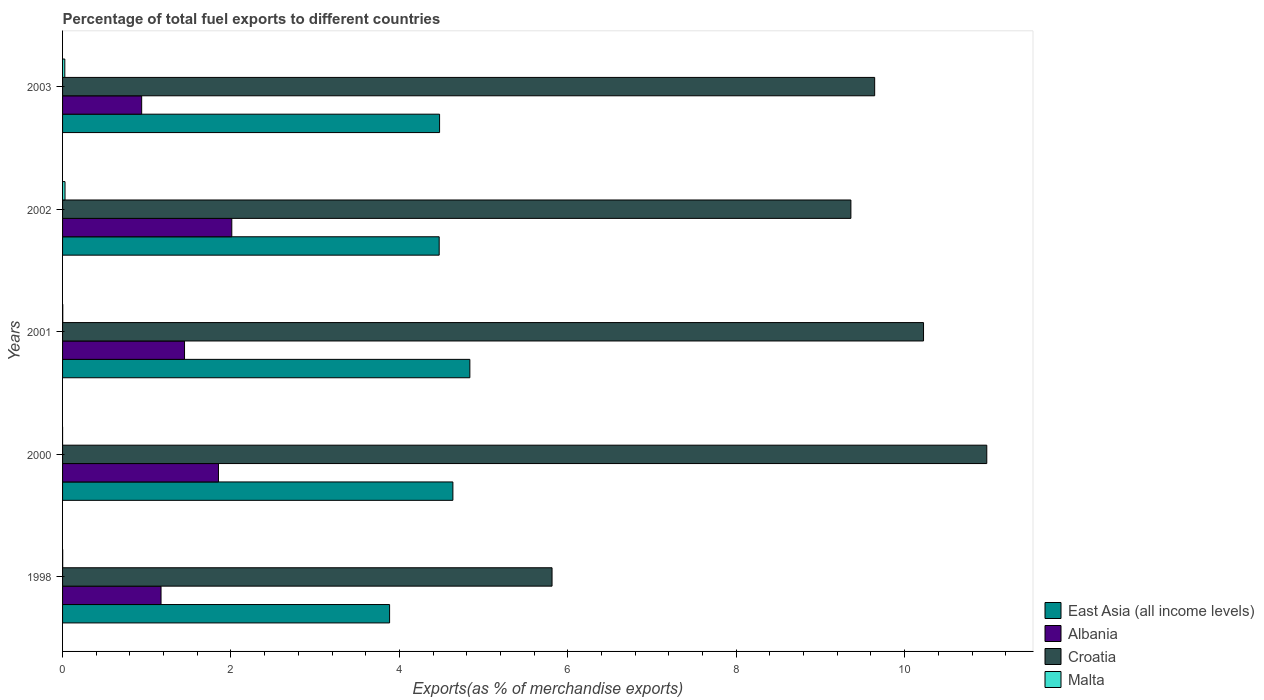Are the number of bars per tick equal to the number of legend labels?
Offer a very short reply. Yes. How many bars are there on the 4th tick from the bottom?
Your answer should be very brief. 4. In how many cases, is the number of bars for a given year not equal to the number of legend labels?
Provide a short and direct response. 0. What is the percentage of exports to different countries in Croatia in 2003?
Make the answer very short. 9.64. Across all years, what is the maximum percentage of exports to different countries in East Asia (all income levels)?
Provide a short and direct response. 4.84. Across all years, what is the minimum percentage of exports to different countries in East Asia (all income levels)?
Offer a terse response. 3.88. In which year was the percentage of exports to different countries in Croatia maximum?
Offer a terse response. 2000. What is the total percentage of exports to different countries in Albania in the graph?
Ensure brevity in your answer.  7.42. What is the difference between the percentage of exports to different countries in East Asia (all income levels) in 2000 and that in 2002?
Keep it short and to the point. 0.16. What is the difference between the percentage of exports to different countries in Albania in 2000 and the percentage of exports to different countries in East Asia (all income levels) in 1998?
Provide a short and direct response. -2.03. What is the average percentage of exports to different countries in Croatia per year?
Offer a very short reply. 9.2. In the year 2000, what is the difference between the percentage of exports to different countries in Malta and percentage of exports to different countries in Croatia?
Offer a terse response. -10.98. What is the ratio of the percentage of exports to different countries in Albania in 2001 to that in 2003?
Your response must be concise. 1.54. Is the difference between the percentage of exports to different countries in Malta in 2000 and 2003 greater than the difference between the percentage of exports to different countries in Croatia in 2000 and 2003?
Offer a very short reply. No. What is the difference between the highest and the second highest percentage of exports to different countries in East Asia (all income levels)?
Offer a very short reply. 0.2. What is the difference between the highest and the lowest percentage of exports to different countries in Albania?
Your answer should be very brief. 1.07. Is the sum of the percentage of exports to different countries in Malta in 2002 and 2003 greater than the maximum percentage of exports to different countries in Croatia across all years?
Your answer should be very brief. No. What does the 2nd bar from the top in 2003 represents?
Provide a short and direct response. Croatia. What does the 4th bar from the bottom in 2000 represents?
Make the answer very short. Malta. Is it the case that in every year, the sum of the percentage of exports to different countries in East Asia (all income levels) and percentage of exports to different countries in Albania is greater than the percentage of exports to different countries in Malta?
Your response must be concise. Yes. How many bars are there?
Offer a terse response. 20. How many years are there in the graph?
Your answer should be compact. 5. What is the difference between two consecutive major ticks on the X-axis?
Offer a very short reply. 2. Does the graph contain any zero values?
Offer a terse response. No. How many legend labels are there?
Provide a short and direct response. 4. What is the title of the graph?
Your response must be concise. Percentage of total fuel exports to different countries. Does "Honduras" appear as one of the legend labels in the graph?
Give a very brief answer. No. What is the label or title of the X-axis?
Provide a succinct answer. Exports(as % of merchandise exports). What is the label or title of the Y-axis?
Provide a succinct answer. Years. What is the Exports(as % of merchandise exports) of East Asia (all income levels) in 1998?
Ensure brevity in your answer.  3.88. What is the Exports(as % of merchandise exports) in Albania in 1998?
Offer a very short reply. 1.17. What is the Exports(as % of merchandise exports) of Croatia in 1998?
Your response must be concise. 5.81. What is the Exports(as % of merchandise exports) in Malta in 1998?
Make the answer very short. 0. What is the Exports(as % of merchandise exports) in East Asia (all income levels) in 2000?
Give a very brief answer. 4.64. What is the Exports(as % of merchandise exports) in Albania in 2000?
Offer a very short reply. 1.85. What is the Exports(as % of merchandise exports) of Croatia in 2000?
Provide a succinct answer. 10.98. What is the Exports(as % of merchandise exports) in Malta in 2000?
Give a very brief answer. 3.27668183292656e-5. What is the Exports(as % of merchandise exports) in East Asia (all income levels) in 2001?
Offer a very short reply. 4.84. What is the Exports(as % of merchandise exports) of Albania in 2001?
Provide a short and direct response. 1.45. What is the Exports(as % of merchandise exports) in Croatia in 2001?
Keep it short and to the point. 10.22. What is the Exports(as % of merchandise exports) in Malta in 2001?
Offer a very short reply. 0. What is the Exports(as % of merchandise exports) of East Asia (all income levels) in 2002?
Your answer should be very brief. 4.47. What is the Exports(as % of merchandise exports) in Albania in 2002?
Provide a succinct answer. 2.01. What is the Exports(as % of merchandise exports) in Croatia in 2002?
Keep it short and to the point. 9.36. What is the Exports(as % of merchandise exports) of Malta in 2002?
Provide a short and direct response. 0.03. What is the Exports(as % of merchandise exports) in East Asia (all income levels) in 2003?
Ensure brevity in your answer.  4.48. What is the Exports(as % of merchandise exports) in Albania in 2003?
Your response must be concise. 0.94. What is the Exports(as % of merchandise exports) in Croatia in 2003?
Provide a short and direct response. 9.64. What is the Exports(as % of merchandise exports) in Malta in 2003?
Make the answer very short. 0.03. Across all years, what is the maximum Exports(as % of merchandise exports) of East Asia (all income levels)?
Your answer should be compact. 4.84. Across all years, what is the maximum Exports(as % of merchandise exports) of Albania?
Give a very brief answer. 2.01. Across all years, what is the maximum Exports(as % of merchandise exports) in Croatia?
Provide a short and direct response. 10.98. Across all years, what is the maximum Exports(as % of merchandise exports) in Malta?
Give a very brief answer. 0.03. Across all years, what is the minimum Exports(as % of merchandise exports) of East Asia (all income levels)?
Your answer should be compact. 3.88. Across all years, what is the minimum Exports(as % of merchandise exports) in Albania?
Give a very brief answer. 0.94. Across all years, what is the minimum Exports(as % of merchandise exports) in Croatia?
Provide a short and direct response. 5.81. Across all years, what is the minimum Exports(as % of merchandise exports) in Malta?
Make the answer very short. 3.27668183292656e-5. What is the total Exports(as % of merchandise exports) of East Asia (all income levels) in the graph?
Offer a very short reply. 22.3. What is the total Exports(as % of merchandise exports) of Albania in the graph?
Provide a short and direct response. 7.42. What is the total Exports(as % of merchandise exports) of Croatia in the graph?
Give a very brief answer. 46.02. What is the total Exports(as % of merchandise exports) in Malta in the graph?
Your answer should be compact. 0.06. What is the difference between the Exports(as % of merchandise exports) of East Asia (all income levels) in 1998 and that in 2000?
Your response must be concise. -0.75. What is the difference between the Exports(as % of merchandise exports) in Albania in 1998 and that in 2000?
Offer a very short reply. -0.68. What is the difference between the Exports(as % of merchandise exports) in Croatia in 1998 and that in 2000?
Your answer should be very brief. -5.16. What is the difference between the Exports(as % of merchandise exports) in Malta in 1998 and that in 2000?
Your answer should be compact. 0. What is the difference between the Exports(as % of merchandise exports) of East Asia (all income levels) in 1998 and that in 2001?
Ensure brevity in your answer.  -0.95. What is the difference between the Exports(as % of merchandise exports) of Albania in 1998 and that in 2001?
Your answer should be very brief. -0.28. What is the difference between the Exports(as % of merchandise exports) in Croatia in 1998 and that in 2001?
Your response must be concise. -4.41. What is the difference between the Exports(as % of merchandise exports) in Malta in 1998 and that in 2001?
Provide a succinct answer. -0. What is the difference between the Exports(as % of merchandise exports) in East Asia (all income levels) in 1998 and that in 2002?
Your response must be concise. -0.59. What is the difference between the Exports(as % of merchandise exports) in Albania in 1998 and that in 2002?
Your answer should be very brief. -0.84. What is the difference between the Exports(as % of merchandise exports) of Croatia in 1998 and that in 2002?
Your response must be concise. -3.55. What is the difference between the Exports(as % of merchandise exports) in Malta in 1998 and that in 2002?
Offer a terse response. -0.03. What is the difference between the Exports(as % of merchandise exports) in East Asia (all income levels) in 1998 and that in 2003?
Offer a terse response. -0.59. What is the difference between the Exports(as % of merchandise exports) in Albania in 1998 and that in 2003?
Ensure brevity in your answer.  0.23. What is the difference between the Exports(as % of merchandise exports) of Croatia in 1998 and that in 2003?
Provide a succinct answer. -3.83. What is the difference between the Exports(as % of merchandise exports) of Malta in 1998 and that in 2003?
Your answer should be compact. -0.03. What is the difference between the Exports(as % of merchandise exports) of East Asia (all income levels) in 2000 and that in 2001?
Provide a short and direct response. -0.2. What is the difference between the Exports(as % of merchandise exports) of Albania in 2000 and that in 2001?
Provide a succinct answer. 0.4. What is the difference between the Exports(as % of merchandise exports) in Croatia in 2000 and that in 2001?
Keep it short and to the point. 0.75. What is the difference between the Exports(as % of merchandise exports) in Malta in 2000 and that in 2001?
Provide a short and direct response. -0. What is the difference between the Exports(as % of merchandise exports) in East Asia (all income levels) in 2000 and that in 2002?
Ensure brevity in your answer.  0.16. What is the difference between the Exports(as % of merchandise exports) in Albania in 2000 and that in 2002?
Offer a terse response. -0.16. What is the difference between the Exports(as % of merchandise exports) of Croatia in 2000 and that in 2002?
Give a very brief answer. 1.61. What is the difference between the Exports(as % of merchandise exports) in Malta in 2000 and that in 2002?
Make the answer very short. -0.03. What is the difference between the Exports(as % of merchandise exports) in East Asia (all income levels) in 2000 and that in 2003?
Offer a terse response. 0.16. What is the difference between the Exports(as % of merchandise exports) in Albania in 2000 and that in 2003?
Provide a succinct answer. 0.91. What is the difference between the Exports(as % of merchandise exports) in Croatia in 2000 and that in 2003?
Give a very brief answer. 1.33. What is the difference between the Exports(as % of merchandise exports) in Malta in 2000 and that in 2003?
Offer a terse response. -0.03. What is the difference between the Exports(as % of merchandise exports) of East Asia (all income levels) in 2001 and that in 2002?
Give a very brief answer. 0.36. What is the difference between the Exports(as % of merchandise exports) in Albania in 2001 and that in 2002?
Your answer should be compact. -0.56. What is the difference between the Exports(as % of merchandise exports) of Croatia in 2001 and that in 2002?
Your answer should be very brief. 0.86. What is the difference between the Exports(as % of merchandise exports) in Malta in 2001 and that in 2002?
Provide a succinct answer. -0.03. What is the difference between the Exports(as % of merchandise exports) of East Asia (all income levels) in 2001 and that in 2003?
Give a very brief answer. 0.36. What is the difference between the Exports(as % of merchandise exports) in Albania in 2001 and that in 2003?
Keep it short and to the point. 0.51. What is the difference between the Exports(as % of merchandise exports) of Croatia in 2001 and that in 2003?
Your answer should be very brief. 0.58. What is the difference between the Exports(as % of merchandise exports) in Malta in 2001 and that in 2003?
Make the answer very short. -0.02. What is the difference between the Exports(as % of merchandise exports) in East Asia (all income levels) in 2002 and that in 2003?
Ensure brevity in your answer.  -0. What is the difference between the Exports(as % of merchandise exports) of Albania in 2002 and that in 2003?
Your response must be concise. 1.07. What is the difference between the Exports(as % of merchandise exports) of Croatia in 2002 and that in 2003?
Keep it short and to the point. -0.28. What is the difference between the Exports(as % of merchandise exports) of Malta in 2002 and that in 2003?
Keep it short and to the point. 0. What is the difference between the Exports(as % of merchandise exports) of East Asia (all income levels) in 1998 and the Exports(as % of merchandise exports) of Albania in 2000?
Offer a terse response. 2.03. What is the difference between the Exports(as % of merchandise exports) in East Asia (all income levels) in 1998 and the Exports(as % of merchandise exports) in Croatia in 2000?
Offer a terse response. -7.09. What is the difference between the Exports(as % of merchandise exports) of East Asia (all income levels) in 1998 and the Exports(as % of merchandise exports) of Malta in 2000?
Your answer should be very brief. 3.88. What is the difference between the Exports(as % of merchandise exports) in Albania in 1998 and the Exports(as % of merchandise exports) in Croatia in 2000?
Offer a terse response. -9.81. What is the difference between the Exports(as % of merchandise exports) of Albania in 1998 and the Exports(as % of merchandise exports) of Malta in 2000?
Your answer should be compact. 1.17. What is the difference between the Exports(as % of merchandise exports) of Croatia in 1998 and the Exports(as % of merchandise exports) of Malta in 2000?
Your response must be concise. 5.81. What is the difference between the Exports(as % of merchandise exports) of East Asia (all income levels) in 1998 and the Exports(as % of merchandise exports) of Albania in 2001?
Make the answer very short. 2.44. What is the difference between the Exports(as % of merchandise exports) in East Asia (all income levels) in 1998 and the Exports(as % of merchandise exports) in Croatia in 2001?
Give a very brief answer. -6.34. What is the difference between the Exports(as % of merchandise exports) of East Asia (all income levels) in 1998 and the Exports(as % of merchandise exports) of Malta in 2001?
Provide a succinct answer. 3.88. What is the difference between the Exports(as % of merchandise exports) of Albania in 1998 and the Exports(as % of merchandise exports) of Croatia in 2001?
Offer a very short reply. -9.05. What is the difference between the Exports(as % of merchandise exports) in Albania in 1998 and the Exports(as % of merchandise exports) in Malta in 2001?
Offer a very short reply. 1.17. What is the difference between the Exports(as % of merchandise exports) in Croatia in 1998 and the Exports(as % of merchandise exports) in Malta in 2001?
Offer a terse response. 5.81. What is the difference between the Exports(as % of merchandise exports) of East Asia (all income levels) in 1998 and the Exports(as % of merchandise exports) of Albania in 2002?
Your answer should be very brief. 1.87. What is the difference between the Exports(as % of merchandise exports) in East Asia (all income levels) in 1998 and the Exports(as % of merchandise exports) in Croatia in 2002?
Give a very brief answer. -5.48. What is the difference between the Exports(as % of merchandise exports) of East Asia (all income levels) in 1998 and the Exports(as % of merchandise exports) of Malta in 2002?
Provide a short and direct response. 3.85. What is the difference between the Exports(as % of merchandise exports) in Albania in 1998 and the Exports(as % of merchandise exports) in Croatia in 2002?
Your response must be concise. -8.19. What is the difference between the Exports(as % of merchandise exports) in Albania in 1998 and the Exports(as % of merchandise exports) in Malta in 2002?
Your response must be concise. 1.14. What is the difference between the Exports(as % of merchandise exports) in Croatia in 1998 and the Exports(as % of merchandise exports) in Malta in 2002?
Give a very brief answer. 5.78. What is the difference between the Exports(as % of merchandise exports) in East Asia (all income levels) in 1998 and the Exports(as % of merchandise exports) in Albania in 2003?
Offer a terse response. 2.94. What is the difference between the Exports(as % of merchandise exports) in East Asia (all income levels) in 1998 and the Exports(as % of merchandise exports) in Croatia in 2003?
Your response must be concise. -5.76. What is the difference between the Exports(as % of merchandise exports) of East Asia (all income levels) in 1998 and the Exports(as % of merchandise exports) of Malta in 2003?
Offer a terse response. 3.86. What is the difference between the Exports(as % of merchandise exports) in Albania in 1998 and the Exports(as % of merchandise exports) in Croatia in 2003?
Ensure brevity in your answer.  -8.47. What is the difference between the Exports(as % of merchandise exports) in Albania in 1998 and the Exports(as % of merchandise exports) in Malta in 2003?
Provide a succinct answer. 1.14. What is the difference between the Exports(as % of merchandise exports) in Croatia in 1998 and the Exports(as % of merchandise exports) in Malta in 2003?
Your answer should be compact. 5.79. What is the difference between the Exports(as % of merchandise exports) in East Asia (all income levels) in 2000 and the Exports(as % of merchandise exports) in Albania in 2001?
Ensure brevity in your answer.  3.19. What is the difference between the Exports(as % of merchandise exports) of East Asia (all income levels) in 2000 and the Exports(as % of merchandise exports) of Croatia in 2001?
Provide a succinct answer. -5.59. What is the difference between the Exports(as % of merchandise exports) in East Asia (all income levels) in 2000 and the Exports(as % of merchandise exports) in Malta in 2001?
Give a very brief answer. 4.63. What is the difference between the Exports(as % of merchandise exports) in Albania in 2000 and the Exports(as % of merchandise exports) in Croatia in 2001?
Keep it short and to the point. -8.37. What is the difference between the Exports(as % of merchandise exports) in Albania in 2000 and the Exports(as % of merchandise exports) in Malta in 2001?
Your answer should be very brief. 1.85. What is the difference between the Exports(as % of merchandise exports) in Croatia in 2000 and the Exports(as % of merchandise exports) in Malta in 2001?
Offer a very short reply. 10.97. What is the difference between the Exports(as % of merchandise exports) of East Asia (all income levels) in 2000 and the Exports(as % of merchandise exports) of Albania in 2002?
Your answer should be very brief. 2.63. What is the difference between the Exports(as % of merchandise exports) in East Asia (all income levels) in 2000 and the Exports(as % of merchandise exports) in Croatia in 2002?
Keep it short and to the point. -4.73. What is the difference between the Exports(as % of merchandise exports) in East Asia (all income levels) in 2000 and the Exports(as % of merchandise exports) in Malta in 2002?
Keep it short and to the point. 4.61. What is the difference between the Exports(as % of merchandise exports) in Albania in 2000 and the Exports(as % of merchandise exports) in Croatia in 2002?
Offer a terse response. -7.51. What is the difference between the Exports(as % of merchandise exports) of Albania in 2000 and the Exports(as % of merchandise exports) of Malta in 2002?
Ensure brevity in your answer.  1.82. What is the difference between the Exports(as % of merchandise exports) of Croatia in 2000 and the Exports(as % of merchandise exports) of Malta in 2002?
Ensure brevity in your answer.  10.95. What is the difference between the Exports(as % of merchandise exports) in East Asia (all income levels) in 2000 and the Exports(as % of merchandise exports) in Albania in 2003?
Offer a very short reply. 3.7. What is the difference between the Exports(as % of merchandise exports) in East Asia (all income levels) in 2000 and the Exports(as % of merchandise exports) in Croatia in 2003?
Provide a short and direct response. -5.01. What is the difference between the Exports(as % of merchandise exports) in East Asia (all income levels) in 2000 and the Exports(as % of merchandise exports) in Malta in 2003?
Your response must be concise. 4.61. What is the difference between the Exports(as % of merchandise exports) in Albania in 2000 and the Exports(as % of merchandise exports) in Croatia in 2003?
Your answer should be very brief. -7.79. What is the difference between the Exports(as % of merchandise exports) of Albania in 2000 and the Exports(as % of merchandise exports) of Malta in 2003?
Your response must be concise. 1.82. What is the difference between the Exports(as % of merchandise exports) of Croatia in 2000 and the Exports(as % of merchandise exports) of Malta in 2003?
Keep it short and to the point. 10.95. What is the difference between the Exports(as % of merchandise exports) in East Asia (all income levels) in 2001 and the Exports(as % of merchandise exports) in Albania in 2002?
Your answer should be very brief. 2.83. What is the difference between the Exports(as % of merchandise exports) of East Asia (all income levels) in 2001 and the Exports(as % of merchandise exports) of Croatia in 2002?
Offer a terse response. -4.52. What is the difference between the Exports(as % of merchandise exports) in East Asia (all income levels) in 2001 and the Exports(as % of merchandise exports) in Malta in 2002?
Your answer should be compact. 4.81. What is the difference between the Exports(as % of merchandise exports) in Albania in 2001 and the Exports(as % of merchandise exports) in Croatia in 2002?
Offer a very short reply. -7.91. What is the difference between the Exports(as % of merchandise exports) in Albania in 2001 and the Exports(as % of merchandise exports) in Malta in 2002?
Ensure brevity in your answer.  1.42. What is the difference between the Exports(as % of merchandise exports) of Croatia in 2001 and the Exports(as % of merchandise exports) of Malta in 2002?
Your answer should be compact. 10.19. What is the difference between the Exports(as % of merchandise exports) of East Asia (all income levels) in 2001 and the Exports(as % of merchandise exports) of Albania in 2003?
Your response must be concise. 3.9. What is the difference between the Exports(as % of merchandise exports) of East Asia (all income levels) in 2001 and the Exports(as % of merchandise exports) of Croatia in 2003?
Ensure brevity in your answer.  -4.81. What is the difference between the Exports(as % of merchandise exports) in East Asia (all income levels) in 2001 and the Exports(as % of merchandise exports) in Malta in 2003?
Your answer should be very brief. 4.81. What is the difference between the Exports(as % of merchandise exports) of Albania in 2001 and the Exports(as % of merchandise exports) of Croatia in 2003?
Keep it short and to the point. -8.2. What is the difference between the Exports(as % of merchandise exports) of Albania in 2001 and the Exports(as % of merchandise exports) of Malta in 2003?
Keep it short and to the point. 1.42. What is the difference between the Exports(as % of merchandise exports) in Croatia in 2001 and the Exports(as % of merchandise exports) in Malta in 2003?
Provide a succinct answer. 10.2. What is the difference between the Exports(as % of merchandise exports) of East Asia (all income levels) in 2002 and the Exports(as % of merchandise exports) of Albania in 2003?
Your answer should be compact. 3.53. What is the difference between the Exports(as % of merchandise exports) of East Asia (all income levels) in 2002 and the Exports(as % of merchandise exports) of Croatia in 2003?
Ensure brevity in your answer.  -5.17. What is the difference between the Exports(as % of merchandise exports) in East Asia (all income levels) in 2002 and the Exports(as % of merchandise exports) in Malta in 2003?
Ensure brevity in your answer.  4.45. What is the difference between the Exports(as % of merchandise exports) in Albania in 2002 and the Exports(as % of merchandise exports) in Croatia in 2003?
Offer a very short reply. -7.63. What is the difference between the Exports(as % of merchandise exports) of Albania in 2002 and the Exports(as % of merchandise exports) of Malta in 2003?
Your answer should be compact. 1.98. What is the difference between the Exports(as % of merchandise exports) in Croatia in 2002 and the Exports(as % of merchandise exports) in Malta in 2003?
Make the answer very short. 9.33. What is the average Exports(as % of merchandise exports) of East Asia (all income levels) per year?
Your answer should be compact. 4.46. What is the average Exports(as % of merchandise exports) of Albania per year?
Offer a terse response. 1.48. What is the average Exports(as % of merchandise exports) of Croatia per year?
Provide a short and direct response. 9.2. What is the average Exports(as % of merchandise exports) of Malta per year?
Your answer should be very brief. 0.01. In the year 1998, what is the difference between the Exports(as % of merchandise exports) in East Asia (all income levels) and Exports(as % of merchandise exports) in Albania?
Your response must be concise. 2.71. In the year 1998, what is the difference between the Exports(as % of merchandise exports) in East Asia (all income levels) and Exports(as % of merchandise exports) in Croatia?
Provide a short and direct response. -1.93. In the year 1998, what is the difference between the Exports(as % of merchandise exports) in East Asia (all income levels) and Exports(as % of merchandise exports) in Malta?
Make the answer very short. 3.88. In the year 1998, what is the difference between the Exports(as % of merchandise exports) of Albania and Exports(as % of merchandise exports) of Croatia?
Offer a very short reply. -4.64. In the year 1998, what is the difference between the Exports(as % of merchandise exports) of Albania and Exports(as % of merchandise exports) of Malta?
Keep it short and to the point. 1.17. In the year 1998, what is the difference between the Exports(as % of merchandise exports) of Croatia and Exports(as % of merchandise exports) of Malta?
Your answer should be compact. 5.81. In the year 2000, what is the difference between the Exports(as % of merchandise exports) in East Asia (all income levels) and Exports(as % of merchandise exports) in Albania?
Provide a short and direct response. 2.78. In the year 2000, what is the difference between the Exports(as % of merchandise exports) in East Asia (all income levels) and Exports(as % of merchandise exports) in Croatia?
Provide a short and direct response. -6.34. In the year 2000, what is the difference between the Exports(as % of merchandise exports) in East Asia (all income levels) and Exports(as % of merchandise exports) in Malta?
Your response must be concise. 4.64. In the year 2000, what is the difference between the Exports(as % of merchandise exports) of Albania and Exports(as % of merchandise exports) of Croatia?
Keep it short and to the point. -9.12. In the year 2000, what is the difference between the Exports(as % of merchandise exports) in Albania and Exports(as % of merchandise exports) in Malta?
Keep it short and to the point. 1.85. In the year 2000, what is the difference between the Exports(as % of merchandise exports) in Croatia and Exports(as % of merchandise exports) in Malta?
Your response must be concise. 10.97. In the year 2001, what is the difference between the Exports(as % of merchandise exports) in East Asia (all income levels) and Exports(as % of merchandise exports) in Albania?
Offer a very short reply. 3.39. In the year 2001, what is the difference between the Exports(as % of merchandise exports) of East Asia (all income levels) and Exports(as % of merchandise exports) of Croatia?
Provide a short and direct response. -5.39. In the year 2001, what is the difference between the Exports(as % of merchandise exports) of East Asia (all income levels) and Exports(as % of merchandise exports) of Malta?
Your answer should be very brief. 4.83. In the year 2001, what is the difference between the Exports(as % of merchandise exports) in Albania and Exports(as % of merchandise exports) in Croatia?
Provide a succinct answer. -8.78. In the year 2001, what is the difference between the Exports(as % of merchandise exports) in Albania and Exports(as % of merchandise exports) in Malta?
Provide a succinct answer. 1.45. In the year 2001, what is the difference between the Exports(as % of merchandise exports) in Croatia and Exports(as % of merchandise exports) in Malta?
Your answer should be compact. 10.22. In the year 2002, what is the difference between the Exports(as % of merchandise exports) in East Asia (all income levels) and Exports(as % of merchandise exports) in Albania?
Offer a terse response. 2.46. In the year 2002, what is the difference between the Exports(as % of merchandise exports) in East Asia (all income levels) and Exports(as % of merchandise exports) in Croatia?
Provide a short and direct response. -4.89. In the year 2002, what is the difference between the Exports(as % of merchandise exports) of East Asia (all income levels) and Exports(as % of merchandise exports) of Malta?
Your answer should be compact. 4.44. In the year 2002, what is the difference between the Exports(as % of merchandise exports) in Albania and Exports(as % of merchandise exports) in Croatia?
Your answer should be very brief. -7.35. In the year 2002, what is the difference between the Exports(as % of merchandise exports) in Albania and Exports(as % of merchandise exports) in Malta?
Give a very brief answer. 1.98. In the year 2002, what is the difference between the Exports(as % of merchandise exports) in Croatia and Exports(as % of merchandise exports) in Malta?
Ensure brevity in your answer.  9.33. In the year 2003, what is the difference between the Exports(as % of merchandise exports) of East Asia (all income levels) and Exports(as % of merchandise exports) of Albania?
Offer a very short reply. 3.54. In the year 2003, what is the difference between the Exports(as % of merchandise exports) in East Asia (all income levels) and Exports(as % of merchandise exports) in Croatia?
Provide a short and direct response. -5.17. In the year 2003, what is the difference between the Exports(as % of merchandise exports) of East Asia (all income levels) and Exports(as % of merchandise exports) of Malta?
Your answer should be compact. 4.45. In the year 2003, what is the difference between the Exports(as % of merchandise exports) of Albania and Exports(as % of merchandise exports) of Croatia?
Give a very brief answer. -8.7. In the year 2003, what is the difference between the Exports(as % of merchandise exports) of Albania and Exports(as % of merchandise exports) of Malta?
Provide a short and direct response. 0.91. In the year 2003, what is the difference between the Exports(as % of merchandise exports) of Croatia and Exports(as % of merchandise exports) of Malta?
Provide a short and direct response. 9.62. What is the ratio of the Exports(as % of merchandise exports) in East Asia (all income levels) in 1998 to that in 2000?
Make the answer very short. 0.84. What is the ratio of the Exports(as % of merchandise exports) of Albania in 1998 to that in 2000?
Make the answer very short. 0.63. What is the ratio of the Exports(as % of merchandise exports) in Croatia in 1998 to that in 2000?
Offer a very short reply. 0.53. What is the ratio of the Exports(as % of merchandise exports) in Malta in 1998 to that in 2000?
Give a very brief answer. 45.64. What is the ratio of the Exports(as % of merchandise exports) in East Asia (all income levels) in 1998 to that in 2001?
Make the answer very short. 0.8. What is the ratio of the Exports(as % of merchandise exports) in Albania in 1998 to that in 2001?
Offer a terse response. 0.81. What is the ratio of the Exports(as % of merchandise exports) in Croatia in 1998 to that in 2001?
Your response must be concise. 0.57. What is the ratio of the Exports(as % of merchandise exports) in Malta in 1998 to that in 2001?
Keep it short and to the point. 0.62. What is the ratio of the Exports(as % of merchandise exports) of East Asia (all income levels) in 1998 to that in 2002?
Provide a succinct answer. 0.87. What is the ratio of the Exports(as % of merchandise exports) in Albania in 1998 to that in 2002?
Your response must be concise. 0.58. What is the ratio of the Exports(as % of merchandise exports) of Croatia in 1998 to that in 2002?
Your response must be concise. 0.62. What is the ratio of the Exports(as % of merchandise exports) in Malta in 1998 to that in 2002?
Provide a succinct answer. 0.05. What is the ratio of the Exports(as % of merchandise exports) of East Asia (all income levels) in 1998 to that in 2003?
Offer a very short reply. 0.87. What is the ratio of the Exports(as % of merchandise exports) in Albania in 1998 to that in 2003?
Your answer should be very brief. 1.24. What is the ratio of the Exports(as % of merchandise exports) in Croatia in 1998 to that in 2003?
Give a very brief answer. 0.6. What is the ratio of the Exports(as % of merchandise exports) of Malta in 1998 to that in 2003?
Keep it short and to the point. 0.06. What is the ratio of the Exports(as % of merchandise exports) in East Asia (all income levels) in 2000 to that in 2001?
Provide a short and direct response. 0.96. What is the ratio of the Exports(as % of merchandise exports) of Albania in 2000 to that in 2001?
Offer a very short reply. 1.28. What is the ratio of the Exports(as % of merchandise exports) in Croatia in 2000 to that in 2001?
Your response must be concise. 1.07. What is the ratio of the Exports(as % of merchandise exports) of Malta in 2000 to that in 2001?
Provide a succinct answer. 0.01. What is the ratio of the Exports(as % of merchandise exports) of East Asia (all income levels) in 2000 to that in 2002?
Give a very brief answer. 1.04. What is the ratio of the Exports(as % of merchandise exports) in Albania in 2000 to that in 2002?
Provide a succinct answer. 0.92. What is the ratio of the Exports(as % of merchandise exports) in Croatia in 2000 to that in 2002?
Your answer should be compact. 1.17. What is the ratio of the Exports(as % of merchandise exports) in Malta in 2000 to that in 2002?
Give a very brief answer. 0. What is the ratio of the Exports(as % of merchandise exports) in East Asia (all income levels) in 2000 to that in 2003?
Offer a very short reply. 1.04. What is the ratio of the Exports(as % of merchandise exports) in Albania in 2000 to that in 2003?
Your answer should be compact. 1.97. What is the ratio of the Exports(as % of merchandise exports) in Croatia in 2000 to that in 2003?
Your answer should be compact. 1.14. What is the ratio of the Exports(as % of merchandise exports) of Malta in 2000 to that in 2003?
Your answer should be compact. 0. What is the ratio of the Exports(as % of merchandise exports) in East Asia (all income levels) in 2001 to that in 2002?
Your answer should be very brief. 1.08. What is the ratio of the Exports(as % of merchandise exports) in Albania in 2001 to that in 2002?
Your answer should be very brief. 0.72. What is the ratio of the Exports(as % of merchandise exports) of Croatia in 2001 to that in 2002?
Keep it short and to the point. 1.09. What is the ratio of the Exports(as % of merchandise exports) in Malta in 2001 to that in 2002?
Keep it short and to the point. 0.08. What is the ratio of the Exports(as % of merchandise exports) in East Asia (all income levels) in 2001 to that in 2003?
Offer a terse response. 1.08. What is the ratio of the Exports(as % of merchandise exports) of Albania in 2001 to that in 2003?
Offer a terse response. 1.54. What is the ratio of the Exports(as % of merchandise exports) in Croatia in 2001 to that in 2003?
Your answer should be very brief. 1.06. What is the ratio of the Exports(as % of merchandise exports) in Malta in 2001 to that in 2003?
Offer a very short reply. 0.09. What is the ratio of the Exports(as % of merchandise exports) of Albania in 2002 to that in 2003?
Your answer should be compact. 2.14. What is the ratio of the Exports(as % of merchandise exports) in Croatia in 2002 to that in 2003?
Offer a very short reply. 0.97. What is the ratio of the Exports(as % of merchandise exports) of Malta in 2002 to that in 2003?
Offer a very short reply. 1.09. What is the difference between the highest and the second highest Exports(as % of merchandise exports) of East Asia (all income levels)?
Provide a short and direct response. 0.2. What is the difference between the highest and the second highest Exports(as % of merchandise exports) in Albania?
Your answer should be very brief. 0.16. What is the difference between the highest and the second highest Exports(as % of merchandise exports) of Croatia?
Give a very brief answer. 0.75. What is the difference between the highest and the second highest Exports(as % of merchandise exports) of Malta?
Keep it short and to the point. 0. What is the difference between the highest and the lowest Exports(as % of merchandise exports) in East Asia (all income levels)?
Your answer should be very brief. 0.95. What is the difference between the highest and the lowest Exports(as % of merchandise exports) of Albania?
Offer a very short reply. 1.07. What is the difference between the highest and the lowest Exports(as % of merchandise exports) of Croatia?
Provide a short and direct response. 5.16. What is the difference between the highest and the lowest Exports(as % of merchandise exports) in Malta?
Make the answer very short. 0.03. 